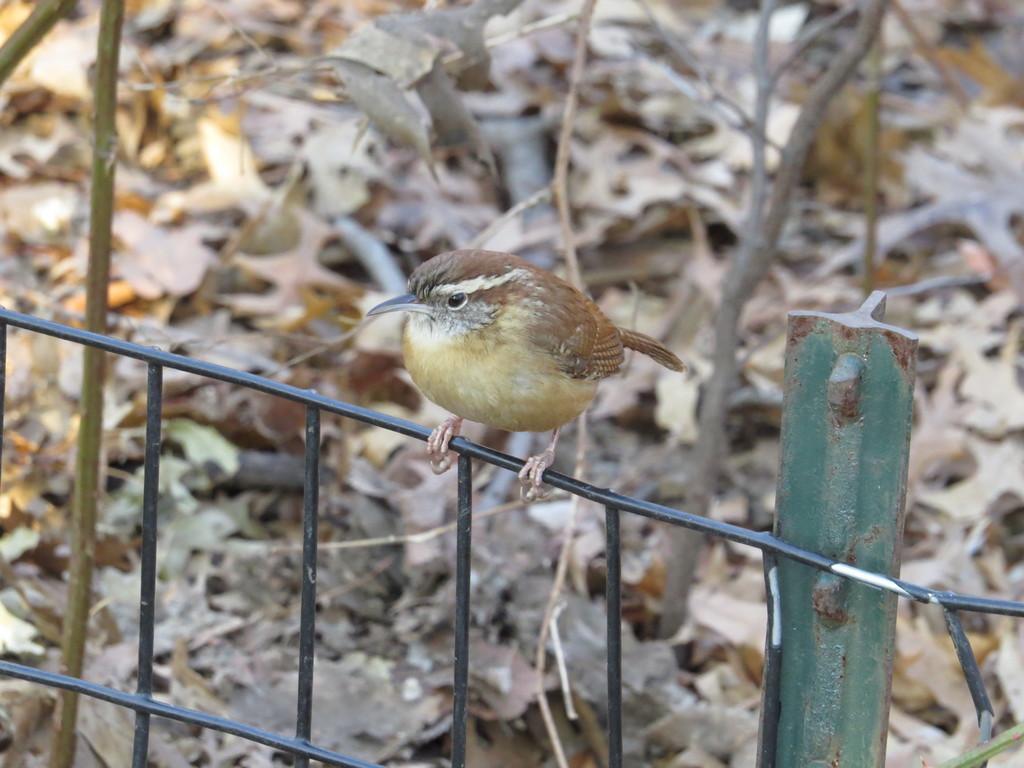In one or two sentences, can you explain what this image depicts? In this picture I can see there is a bird here on the fence and in the backdrop I can see there are dry leaves on the floor and plants. 